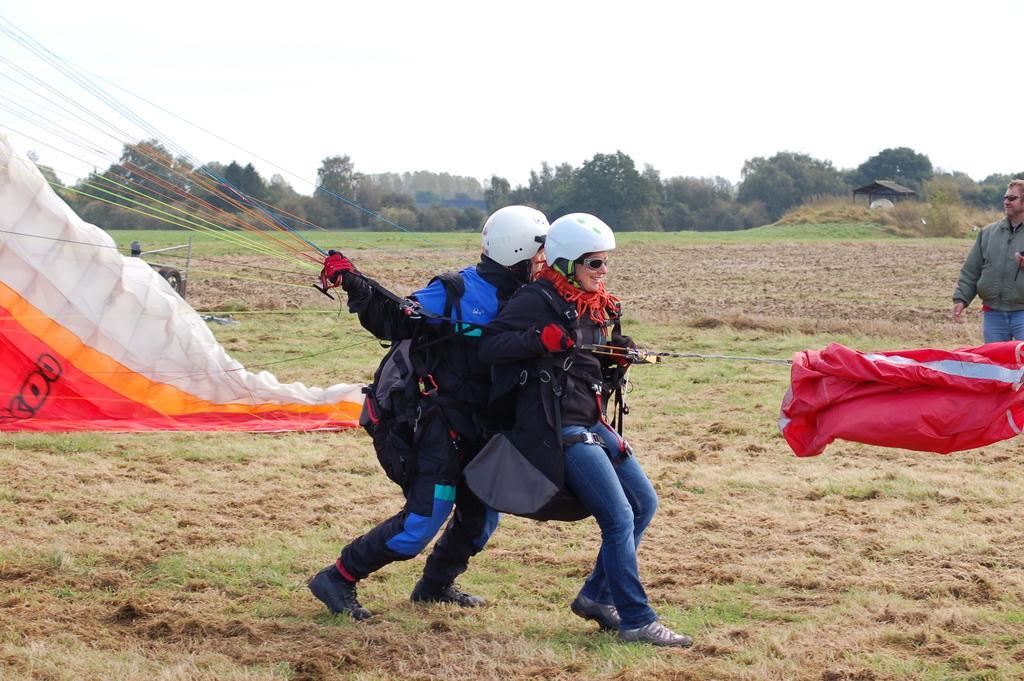Could you give a brief overview of what you see in this image? This picture shows couple of them wore helmets on their heads and holding a parachute with the strings and we see grass on the ground and we see a man standing on the side and we see trees and cloudy sky. 